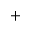Convert formula to latex. <formula><loc_0><loc_0><loc_500><loc_500>^ { + }</formula> 